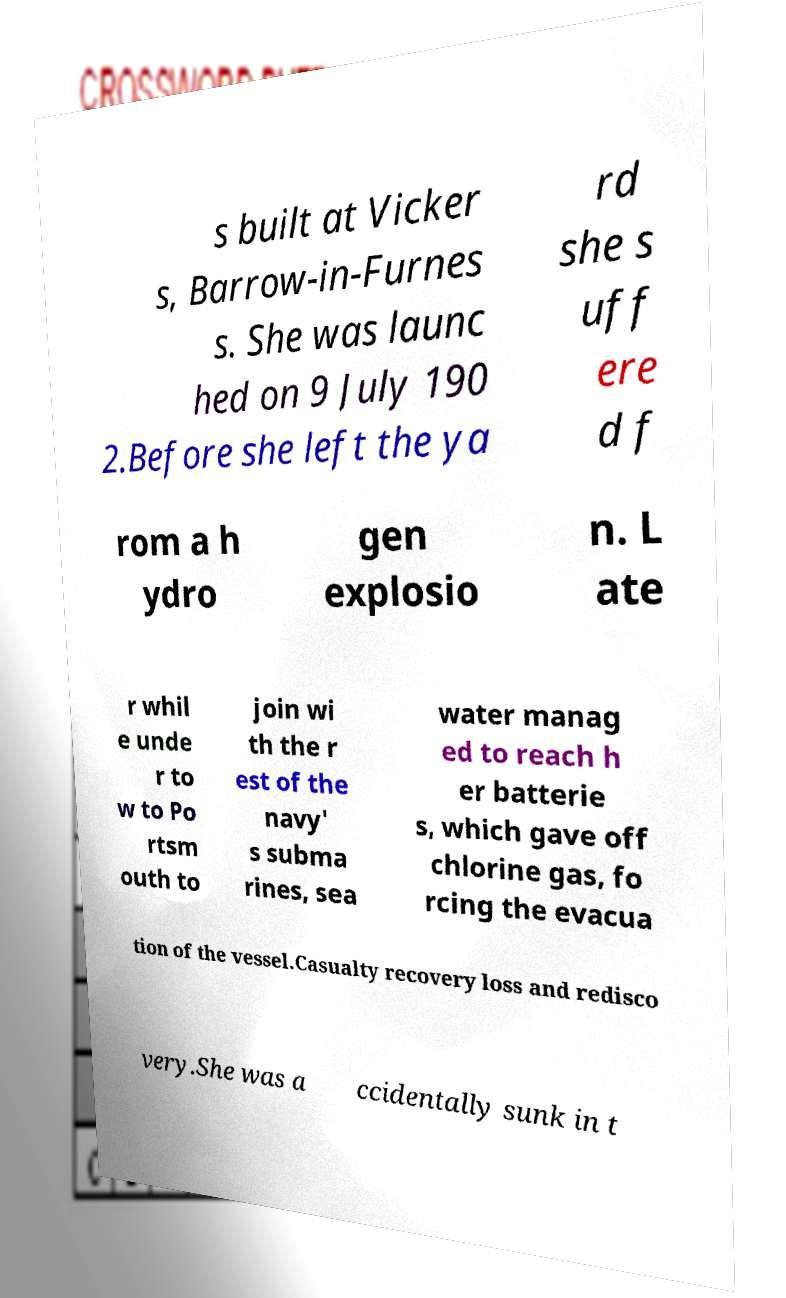For documentation purposes, I need the text within this image transcribed. Could you provide that? s built at Vicker s, Barrow-in-Furnes s. She was launc hed on 9 July 190 2.Before she left the ya rd she s uff ere d f rom a h ydro gen explosio n. L ate r whil e unde r to w to Po rtsm outh to join wi th the r est of the navy' s subma rines, sea water manag ed to reach h er batterie s, which gave off chlorine gas, fo rcing the evacua tion of the vessel.Casualty recovery loss and redisco very.She was a ccidentally sunk in t 